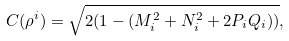Convert formula to latex. <formula><loc_0><loc_0><loc_500><loc_500>C ( \rho ^ { i } ) = \sqrt { 2 ( 1 - ( M _ { i } ^ { 2 } + N _ { i } ^ { 2 } + 2 P _ { i } Q _ { i } ) ) } ,</formula> 